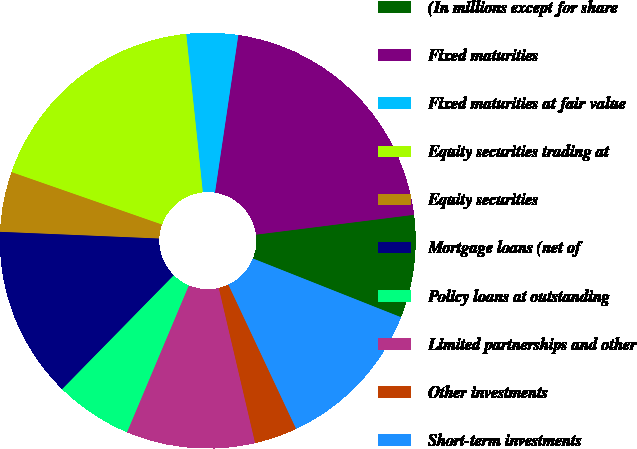Convert chart to OTSL. <chart><loc_0><loc_0><loc_500><loc_500><pie_chart><fcel>(In millions except for share<fcel>Fixed maturities<fcel>Fixed maturities at fair value<fcel>Equity securities trading at<fcel>Equity securities<fcel>Mortgage loans (net of<fcel>Policy loans at outstanding<fcel>Limited partnerships and other<fcel>Other investments<fcel>Short-term investments<nl><fcel>8.0%<fcel>20.67%<fcel>4.0%<fcel>18.0%<fcel>4.67%<fcel>13.33%<fcel>6.0%<fcel>10.0%<fcel>3.33%<fcel>12.0%<nl></chart> 